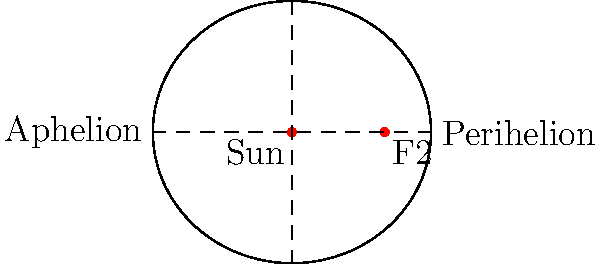In the elliptical orbit of a comet around the Sun, what is the term for the point in the orbit where the comet is closest to the Sun, and how does this relate to the comet's velocity? To answer this question, let's break it down step-by-step:

1. The elliptical orbit of a comet around the Sun is defined by two focal points. One of these focal points is occupied by the Sun.

2. The point in the orbit where the comet is closest to the Sun is called the perihelion. This is labeled in the diagram on the right side of the ellipse.

3. The point farthest from the Sun is called the aphelion, labeled on the left side of the ellipse.

4. According to Kepler's Second Law of Planetary Motion, a line segment joining a planet (or comet) and the Sun sweeps out equal areas during equal intervals of time. This law applies to all objects orbiting the Sun.

5. As a consequence of this law, the comet's velocity is not constant throughout its orbit. It moves faster when it's closer to the Sun and slower when it's farther away.

6. At the perihelion, where the comet is closest to the Sun, it experiences the strongest gravitational pull from the Sun. This results in the comet moving at its maximum velocity at this point.

7. Conversely, at the aphelion, the comet is moving at its slowest velocity.

Therefore, the perihelion is not only the point where the comet is closest to the Sun, but also where it's moving the fastest in its orbit.
Answer: Perihelion; fastest velocity 